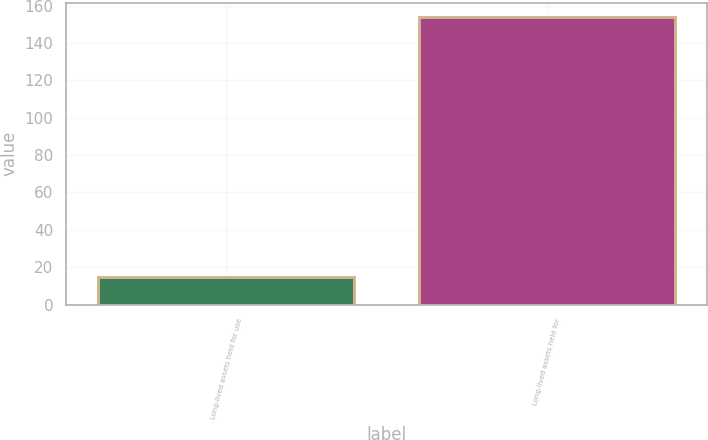Convert chart to OTSL. <chart><loc_0><loc_0><loc_500><loc_500><bar_chart><fcel>Long-lived assets held for use<fcel>Long-lived assets held for<nl><fcel>15<fcel>154<nl></chart> 